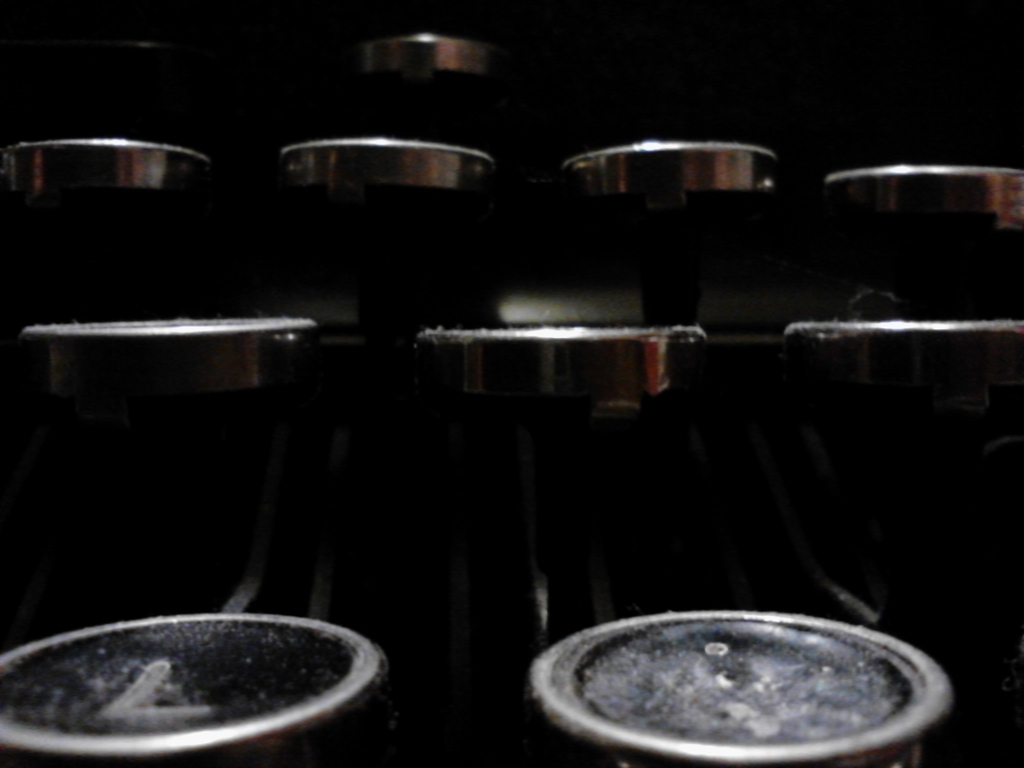What does the lighting and composition tell us about the mood or setting of this scene? The dark background and focused lighting on the metallic elements create a moody and intimate atmosphere. The composition leads the eye across the dials in a horizontal pattern, suggesting precision and control. This could indicate that the setting is a studio or a place where attention to detail is crucial, such as a sound engineer's workspace. 